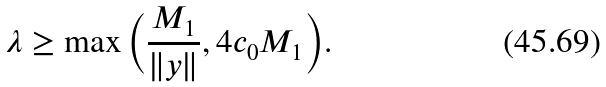<formula> <loc_0><loc_0><loc_500><loc_500>\lambda \geq \max \Big { ( } \frac { M _ { 1 } } { \| y \| } , 4 c _ { 0 } M _ { 1 } \Big { ) } .</formula> 